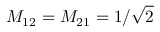Convert formula to latex. <formula><loc_0><loc_0><loc_500><loc_500>M _ { 1 2 } = M _ { 2 1 } = 1 / \sqrt { 2 }</formula> 